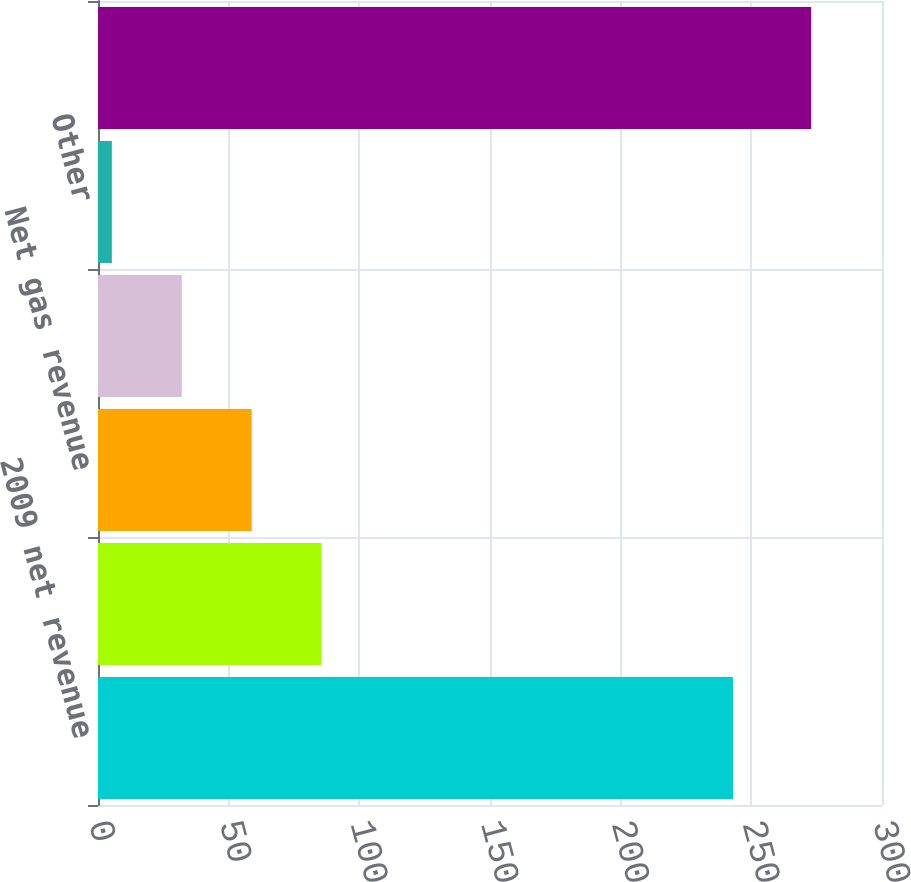Convert chart to OTSL. <chart><loc_0><loc_0><loc_500><loc_500><bar_chart><fcel>2009 net revenue<fcel>Volume/weather<fcel>Net gas revenue<fcel>Effect of 2009 rate case<fcel>Other<fcel>2010 net revenue<nl><fcel>243<fcel>85.58<fcel>58.82<fcel>32.06<fcel>5.3<fcel>272.9<nl></chart> 